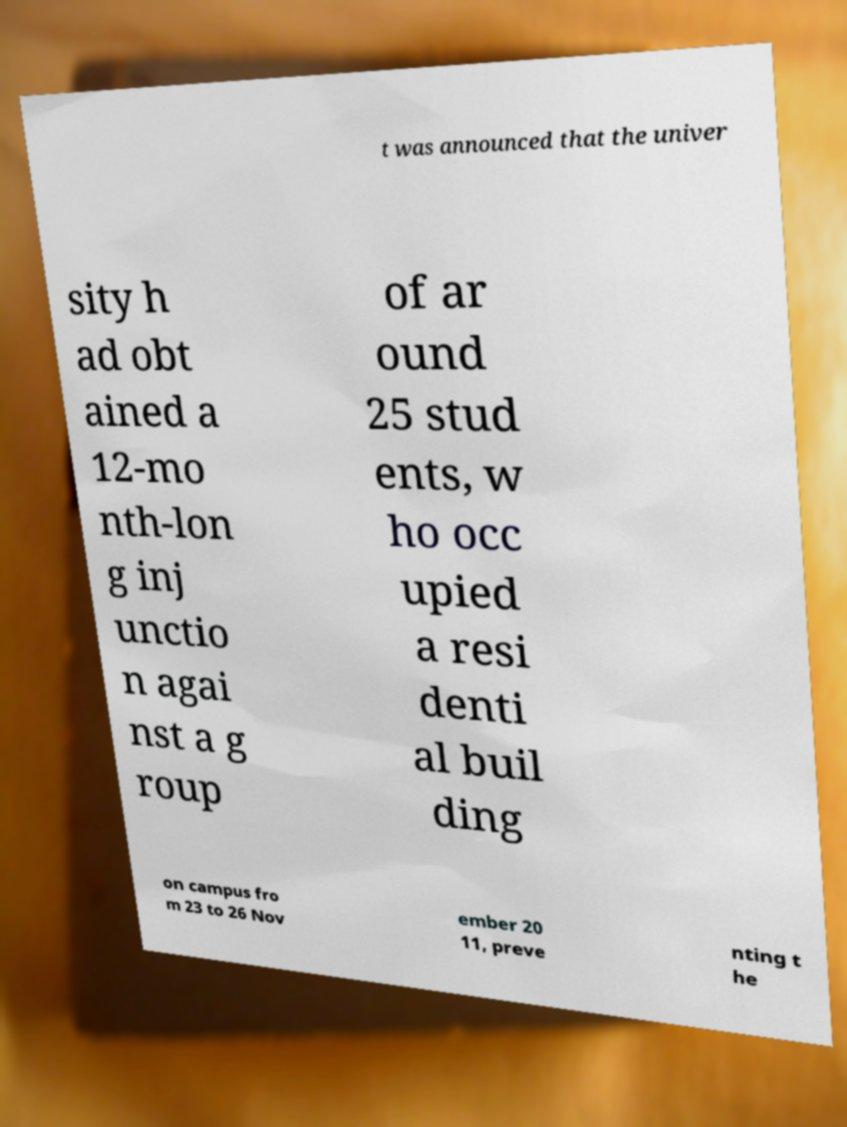Can you accurately transcribe the text from the provided image for me? t was announced that the univer sity h ad obt ained a 12-mo nth-lon g inj unctio n agai nst a g roup of ar ound 25 stud ents, w ho occ upied a resi denti al buil ding on campus fro m 23 to 26 Nov ember 20 11, preve nting t he 